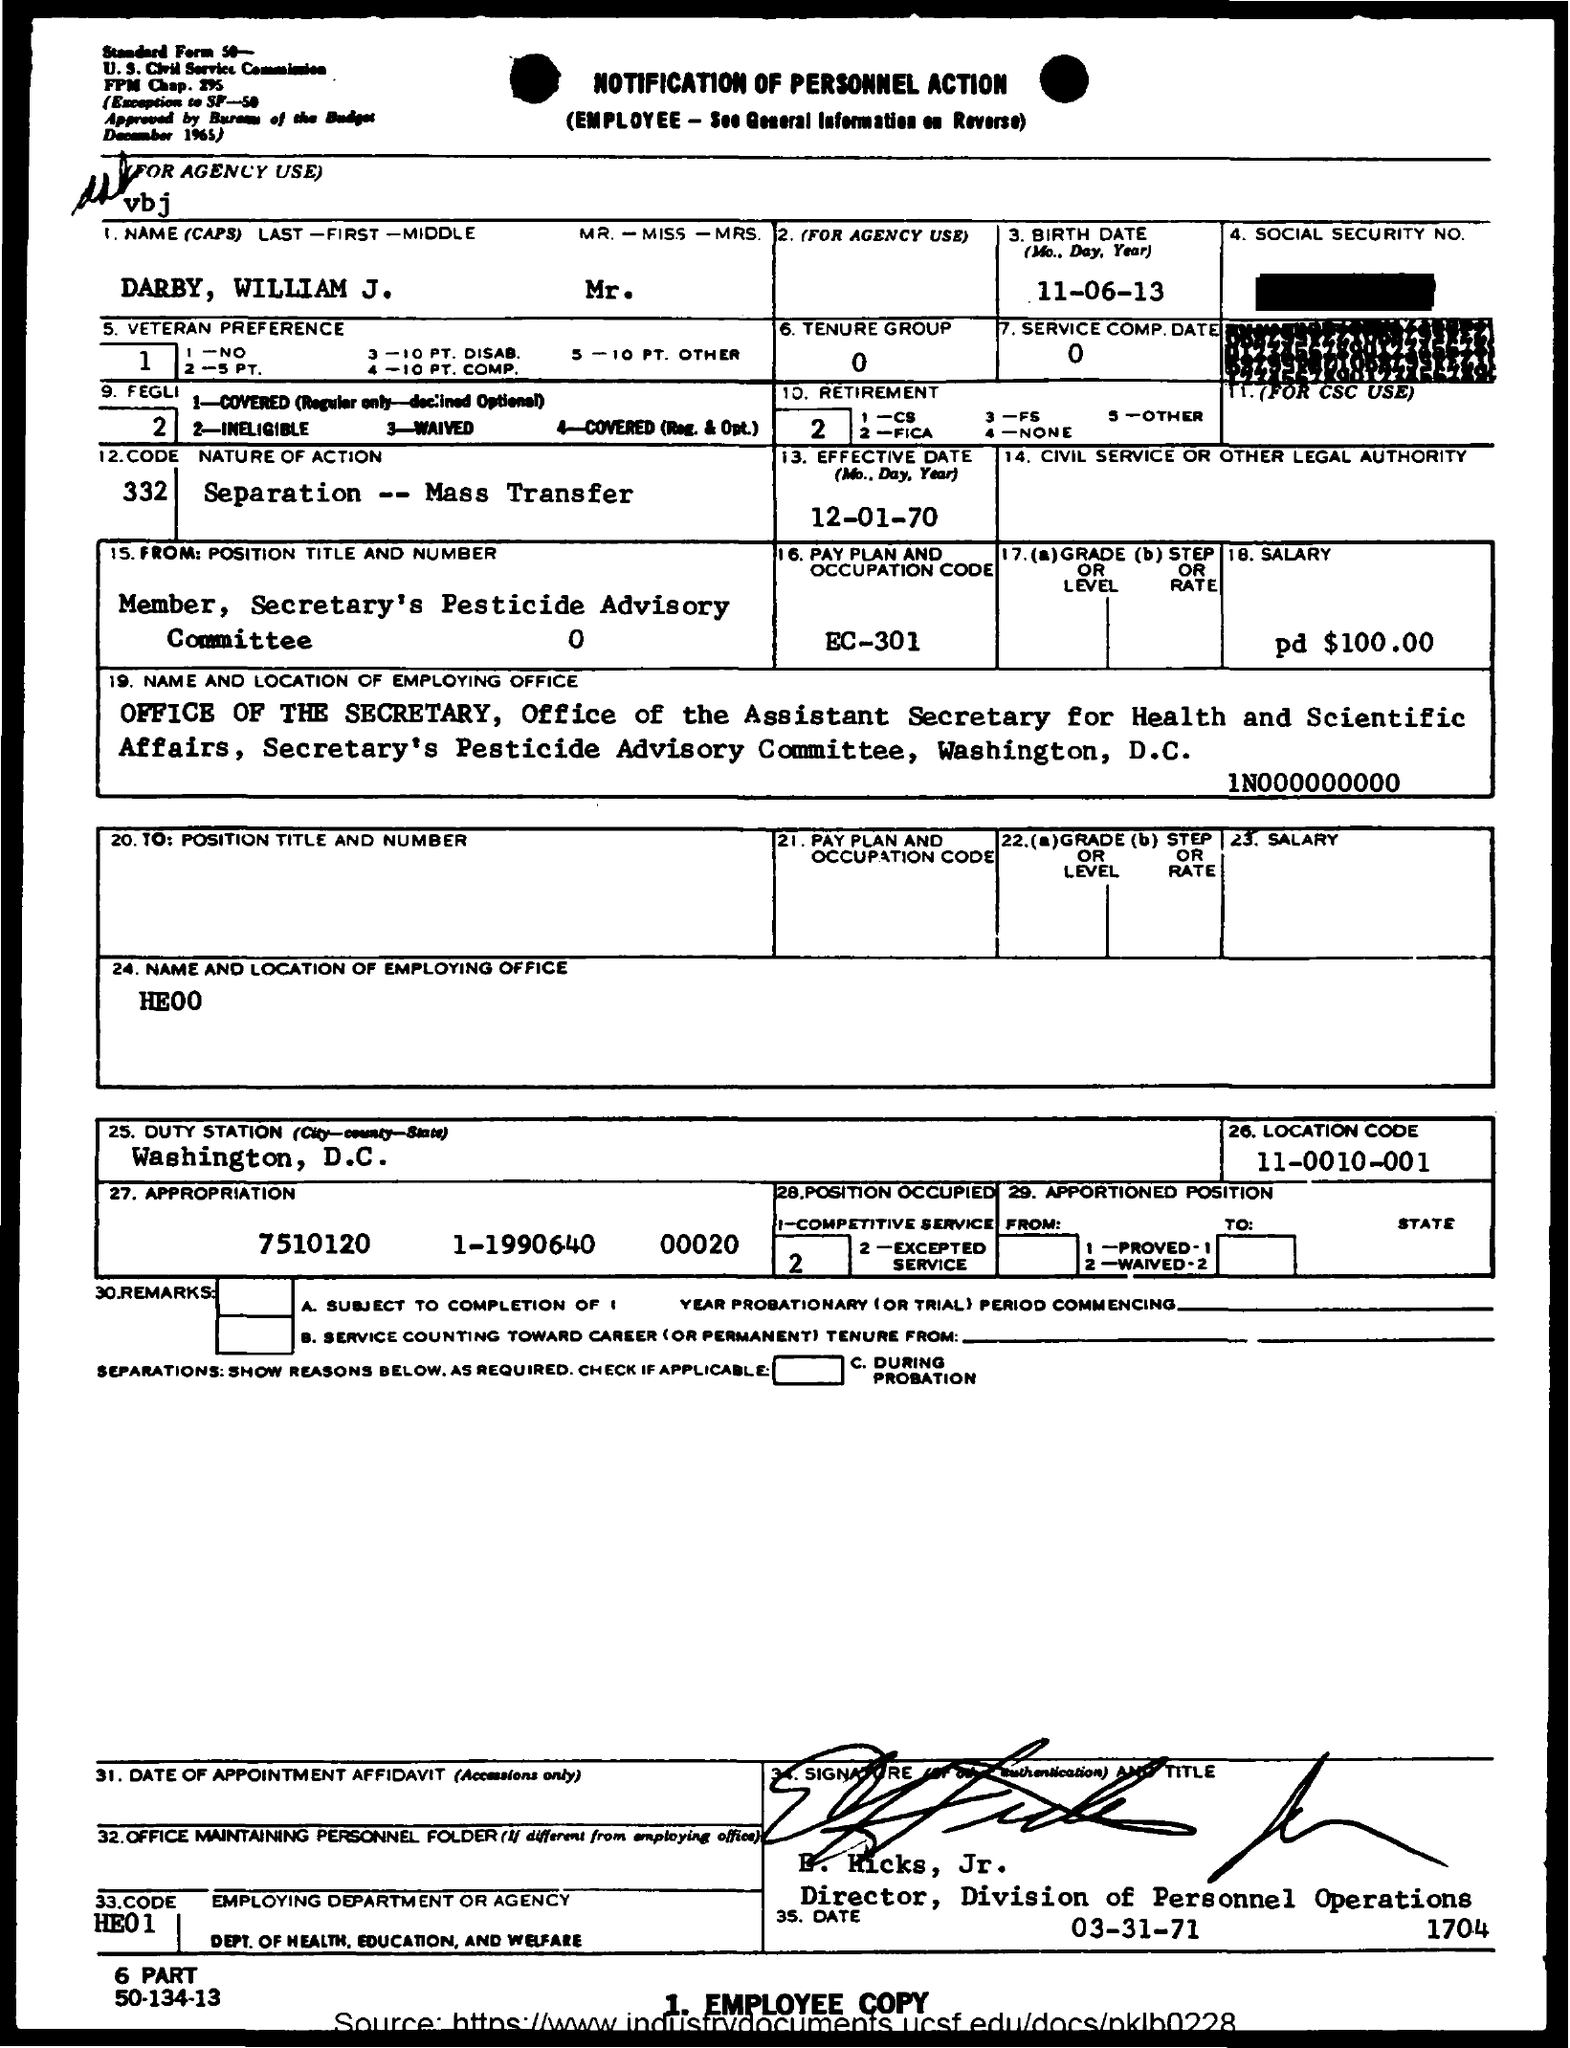Highlight a few significant elements in this photo. The nature of action is separation and mass transfer. The name is Darby, William J. The Tenure Group is a collection of individuals who are members of the Tenure Committee and have been assigned to the Tenure group by the system. Membership in the Tenure Group is determined by a combination of factors, including job classification, department, and tenure status. The Tenure Group is used to facilitate communication and collaboration among members of the Tenure Committee who are responsible for reviewing and making decisions on tenure applications. The duty station is Washington, D.C. The Location Code is 11-0010-001... 